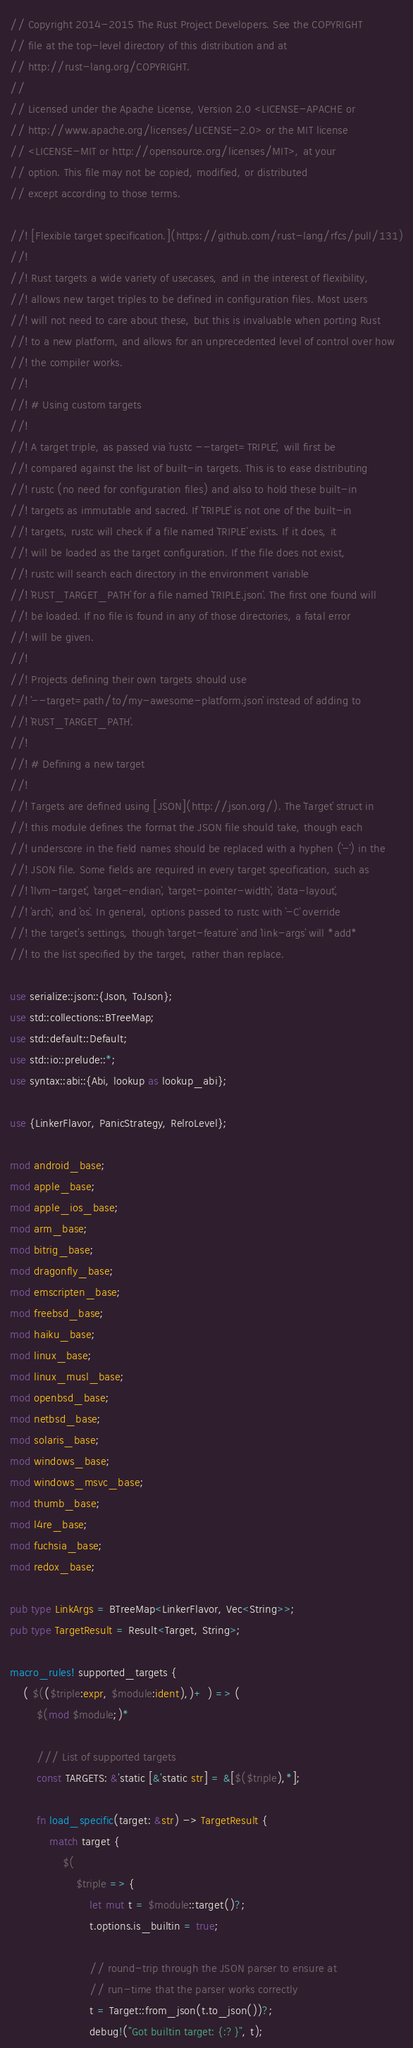<code> <loc_0><loc_0><loc_500><loc_500><_Rust_>// Copyright 2014-2015 The Rust Project Developers. See the COPYRIGHT
// file at the top-level directory of this distribution and at
// http://rust-lang.org/COPYRIGHT.
//
// Licensed under the Apache License, Version 2.0 <LICENSE-APACHE or
// http://www.apache.org/licenses/LICENSE-2.0> or the MIT license
// <LICENSE-MIT or http://opensource.org/licenses/MIT>, at your
// option. This file may not be copied, modified, or distributed
// except according to those terms.

//! [Flexible target specification.](https://github.com/rust-lang/rfcs/pull/131)
//!
//! Rust targets a wide variety of usecases, and in the interest of flexibility,
//! allows new target triples to be defined in configuration files. Most users
//! will not need to care about these, but this is invaluable when porting Rust
//! to a new platform, and allows for an unprecedented level of control over how
//! the compiler works.
//!
//! # Using custom targets
//!
//! A target triple, as passed via `rustc --target=TRIPLE`, will first be
//! compared against the list of built-in targets. This is to ease distributing
//! rustc (no need for configuration files) and also to hold these built-in
//! targets as immutable and sacred. If `TRIPLE` is not one of the built-in
//! targets, rustc will check if a file named `TRIPLE` exists. If it does, it
//! will be loaded as the target configuration. If the file does not exist,
//! rustc will search each directory in the environment variable
//! `RUST_TARGET_PATH` for a file named `TRIPLE.json`. The first one found will
//! be loaded. If no file is found in any of those directories, a fatal error
//! will be given.
//!
//! Projects defining their own targets should use
//! `--target=path/to/my-awesome-platform.json` instead of adding to
//! `RUST_TARGET_PATH`.
//!
//! # Defining a new target
//!
//! Targets are defined using [JSON](http://json.org/). The `Target` struct in
//! this module defines the format the JSON file should take, though each
//! underscore in the field names should be replaced with a hyphen (`-`) in the
//! JSON file. Some fields are required in every target specification, such as
//! `llvm-target`, `target-endian`, `target-pointer-width`, `data-layout`,
//! `arch`, and `os`. In general, options passed to rustc with `-C` override
//! the target's settings, though `target-feature` and `link-args` will *add*
//! to the list specified by the target, rather than replace.

use serialize::json::{Json, ToJson};
use std::collections::BTreeMap;
use std::default::Default;
use std::io::prelude::*;
use syntax::abi::{Abi, lookup as lookup_abi};

use {LinkerFlavor, PanicStrategy, RelroLevel};

mod android_base;
mod apple_base;
mod apple_ios_base;
mod arm_base;
mod bitrig_base;
mod dragonfly_base;
mod emscripten_base;
mod freebsd_base;
mod haiku_base;
mod linux_base;
mod linux_musl_base;
mod openbsd_base;
mod netbsd_base;
mod solaris_base;
mod windows_base;
mod windows_msvc_base;
mod thumb_base;
mod l4re_base;
mod fuchsia_base;
mod redox_base;

pub type LinkArgs = BTreeMap<LinkerFlavor, Vec<String>>;
pub type TargetResult = Result<Target, String>;

macro_rules! supported_targets {
    ( $(($triple:expr, $module:ident),)+ ) => (
        $(mod $module;)*

        /// List of supported targets
        const TARGETS: &'static [&'static str] = &[$($triple),*];

        fn load_specific(target: &str) -> TargetResult {
            match target {
                $(
                    $triple => {
                        let mut t = $module::target()?;
                        t.options.is_builtin = true;

                        // round-trip through the JSON parser to ensure at
                        // run-time that the parser works correctly
                        t = Target::from_json(t.to_json())?;
                        debug!("Got builtin target: {:?}", t);</code> 